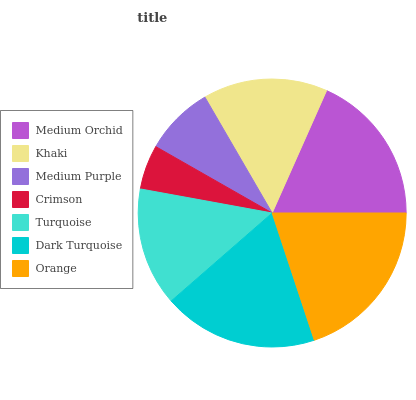Is Crimson the minimum?
Answer yes or no. Yes. Is Orange the maximum?
Answer yes or no. Yes. Is Khaki the minimum?
Answer yes or no. No. Is Khaki the maximum?
Answer yes or no. No. Is Medium Orchid greater than Khaki?
Answer yes or no. Yes. Is Khaki less than Medium Orchid?
Answer yes or no. Yes. Is Khaki greater than Medium Orchid?
Answer yes or no. No. Is Medium Orchid less than Khaki?
Answer yes or no. No. Is Khaki the high median?
Answer yes or no. Yes. Is Khaki the low median?
Answer yes or no. Yes. Is Medium Purple the high median?
Answer yes or no. No. Is Medium Purple the low median?
Answer yes or no. No. 